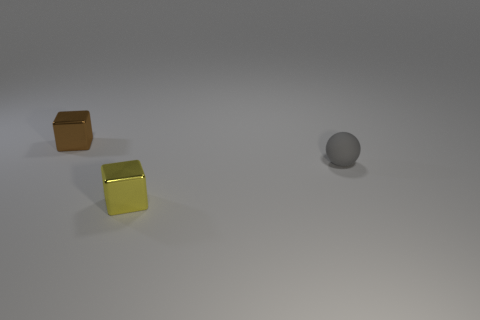Is the number of tiny brown objects less than the number of cyan rubber blocks?
Your response must be concise. No. What material is the gray object that is the same size as the brown object?
Your response must be concise. Rubber. Is the number of green cubes greater than the number of gray balls?
Keep it short and to the point. No. How many other objects are there of the same color as the ball?
Offer a terse response. 0. How many objects are to the left of the rubber object and behind the small yellow block?
Give a very brief answer. 1. Is there anything else that has the same size as the matte thing?
Offer a very short reply. Yes. Are there more brown cubes that are in front of the small sphere than small metallic things in front of the tiny brown metal object?
Your response must be concise. No. There is a small object in front of the small gray matte object; what is it made of?
Make the answer very short. Metal. Do the gray thing and the shiny object in front of the ball have the same shape?
Provide a succinct answer. No. There is a metallic thing in front of the metal cube that is behind the ball; what number of tiny metal cubes are left of it?
Give a very brief answer. 1. 